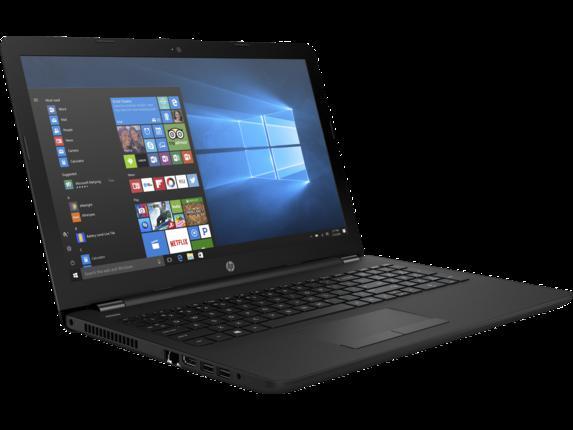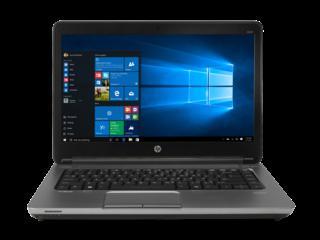The first image is the image on the left, the second image is the image on the right. Examine the images to the left and right. Is the description "All devices feature screens with images on them." accurate? Answer yes or no. Yes. 